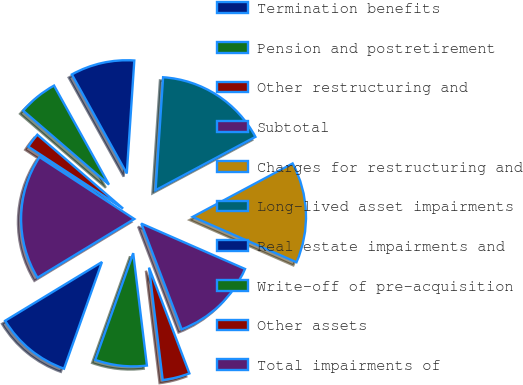Convert chart to OTSL. <chart><loc_0><loc_0><loc_500><loc_500><pie_chart><fcel>Termination benefits<fcel>Pension and postretirement<fcel>Other restructuring and<fcel>Subtotal<fcel>Charges for restructuring and<fcel>Long-lived asset impairments<fcel>Real estate impairments and<fcel>Write-off of pre-acquisition<fcel>Other assets<fcel>Total impairments of<nl><fcel>10.88%<fcel>7.37%<fcel>3.87%<fcel>12.63%<fcel>14.38%<fcel>16.13%<fcel>9.12%<fcel>5.62%<fcel>2.11%<fcel>17.89%<nl></chart> 